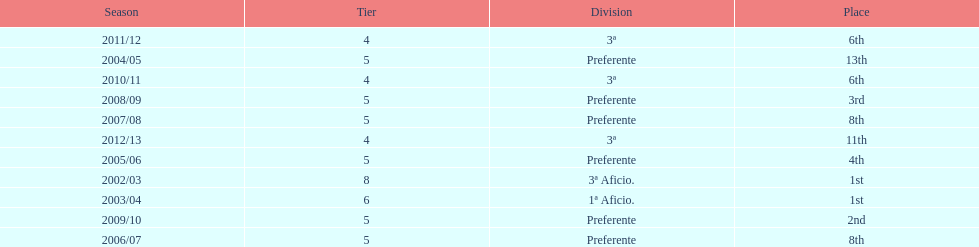How long did the team stay in first place? 2 years. 